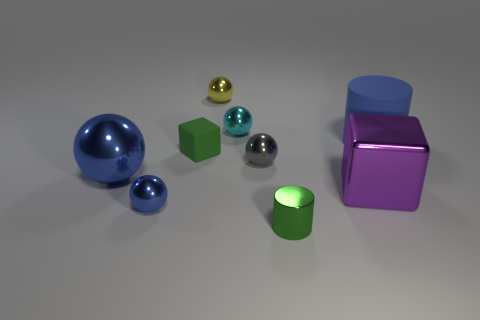What material is the small block?
Your answer should be compact. Rubber. There is a tiny rubber cube; how many large things are right of it?
Your answer should be very brief. 2. Is the rubber cube the same color as the large metal block?
Make the answer very short. No. How many things have the same color as the shiny block?
Offer a terse response. 0. Are there more small brown metal cubes than cyan shiny objects?
Keep it short and to the point. No. There is a blue object that is both to the right of the large sphere and to the left of the cyan ball; what size is it?
Give a very brief answer. Small. Is the material of the tiny ball in front of the tiny gray shiny sphere the same as the blue object that is behind the green matte cube?
Your answer should be compact. No. What is the shape of the purple metal thing that is the same size as the blue matte object?
Offer a very short reply. Cube. Are there fewer green matte objects than big cyan metal cubes?
Offer a terse response. No. Is there a yellow object to the right of the large object that is behind the large metal sphere?
Give a very brief answer. No. 